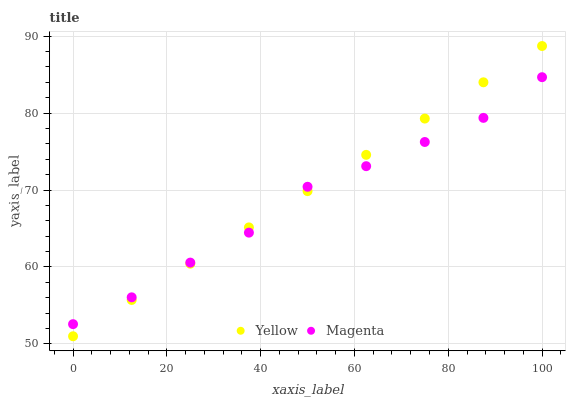Does Magenta have the minimum area under the curve?
Answer yes or no. Yes. Does Yellow have the maximum area under the curve?
Answer yes or no. Yes. Does Yellow have the minimum area under the curve?
Answer yes or no. No. Is Yellow the smoothest?
Answer yes or no. Yes. Is Magenta the roughest?
Answer yes or no. Yes. Is Yellow the roughest?
Answer yes or no. No. Does Yellow have the lowest value?
Answer yes or no. Yes. Does Yellow have the highest value?
Answer yes or no. Yes. Does Yellow intersect Magenta?
Answer yes or no. Yes. Is Yellow less than Magenta?
Answer yes or no. No. Is Yellow greater than Magenta?
Answer yes or no. No. 